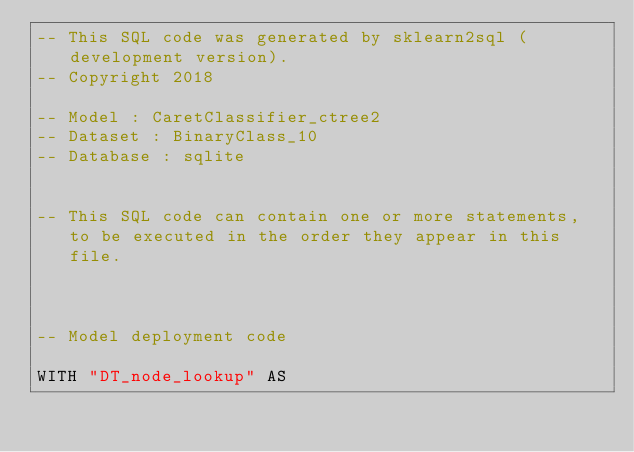Convert code to text. <code><loc_0><loc_0><loc_500><loc_500><_SQL_>-- This SQL code was generated by sklearn2sql (development version).
-- Copyright 2018

-- Model : CaretClassifier_ctree2
-- Dataset : BinaryClass_10
-- Database : sqlite


-- This SQL code can contain one or more statements, to be executed in the order they appear in this file.



-- Model deployment code

WITH "DT_node_lookup" AS </code> 